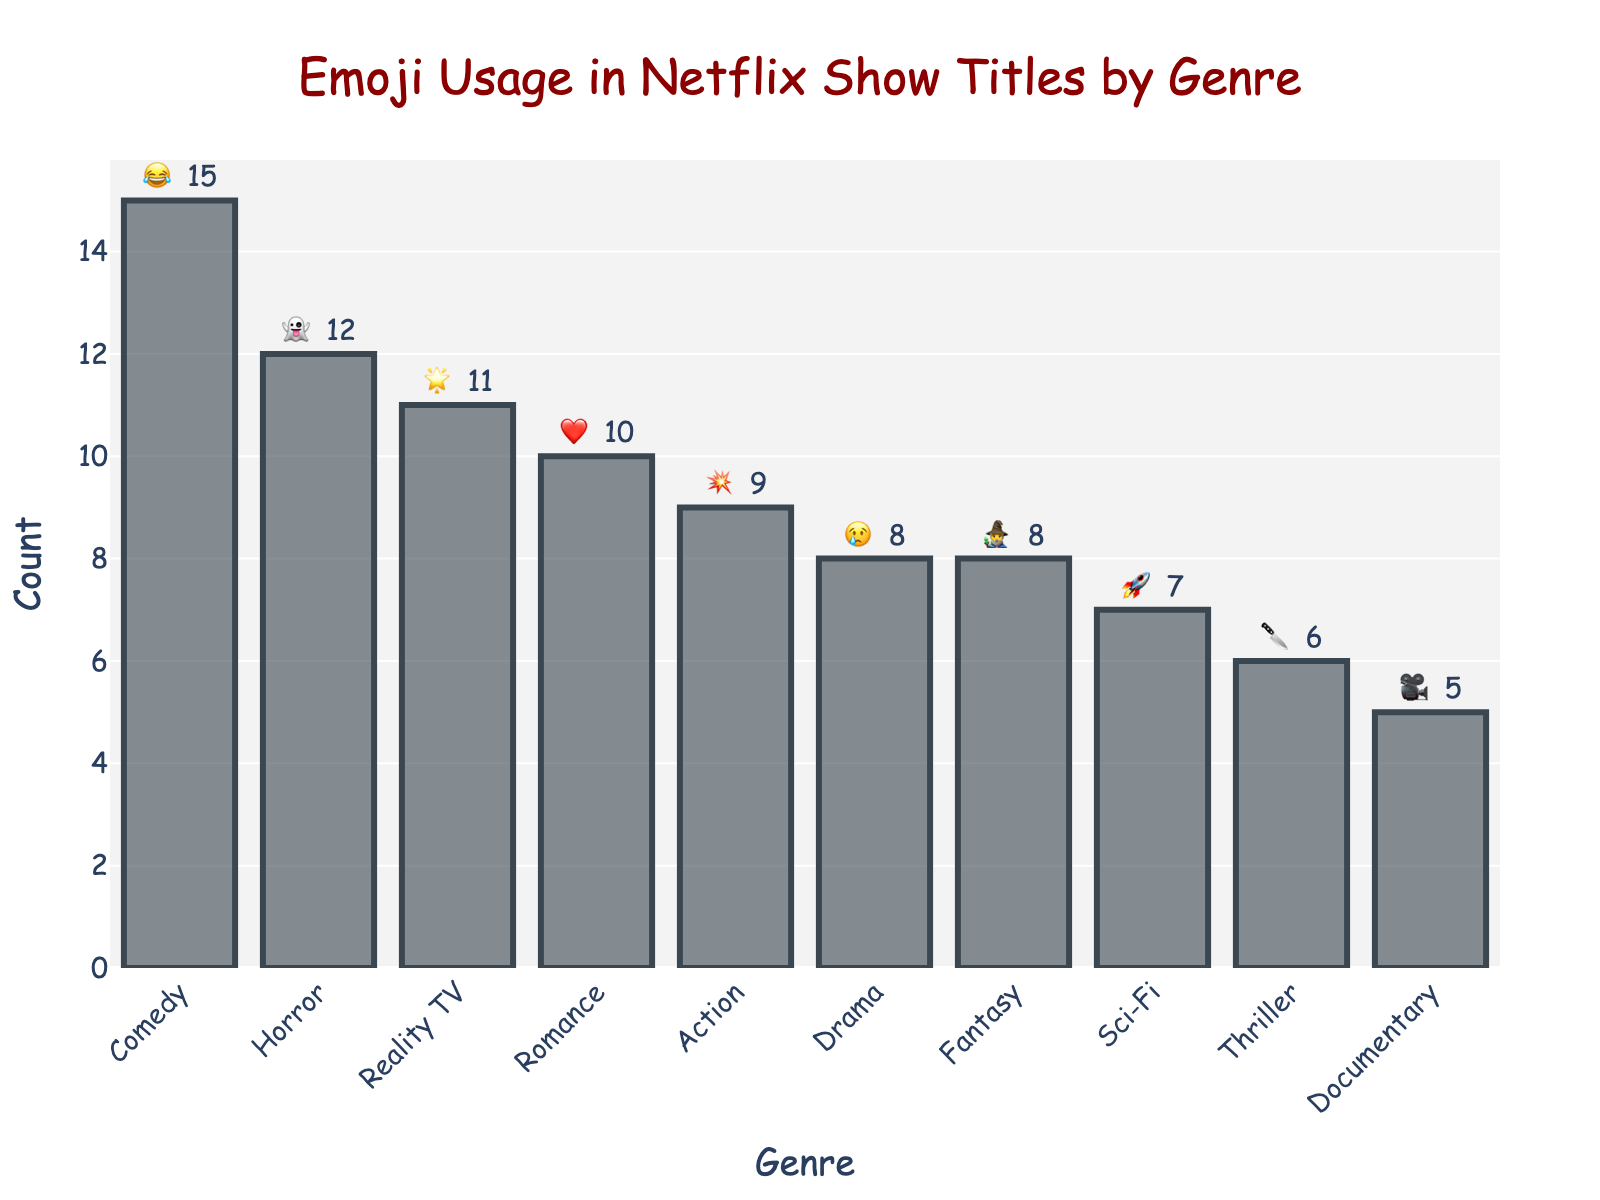Which genre has the highest emoji usage? By examining the height of the bars and the text labels, we can see that Comedy has the highest count of emojis used in Netflix show titles.
Answer: Comedy What is the total number of emojis used in Horror and Fantasy genres? By examining the text labels on the bars, we find that Horror has 12 emojis and Fantasy has 8 emojis. The total is 12 + 8 = 20 emojis.
Answer: 20 Which genre uses the '❤️' emoji, and how many times is it used? Referring to the text labels on the bars, we find that the '❤️' emoji is used in the Romance genre, with a count of 10.
Answer: Romance, 10 How many more times is the '😂' emoji used in Comedy compared to the '🔪' emoji in Thriller? Comedy has 15 emojis (😂) and Thriller has 6 emojis (🔪). The difference is 15 - 6 = 9.
Answer: 9 What is the average number of emojis used across all genres? To find the average, sum up all the emojis and divide by the number of genres. (15 + 8 + 12 + 10 + 9 + 7 + 5 + 6 + 8 + 11) = 91 emojis. There are 10 genres. The average is 91 / 10 = 9.1 emojis.
Answer: 9.1 Which genre uses the emoji '👻', and how many times is it used? By referencing the text labels on the bars, the '👻' emoji is used in the Horror genre, with a count of 12.
Answer: Horror, 12 List the genres that use emojis more than 10 times. By examining the count data, Comedy (15), Horror (12), Romance (10), and Reality TV (11) use emojis more than 10 times.
Answer: Comedy, Horror, Reality TV Among Action, Sci-Fi, and Documentary genres, which one has the highest emoji usage? By comparing the heights of the bars and the text labels, we see that Action has 9 emojis, Sci-Fi has 7 emojis, and Documentary has 5 emojis. The Action genre has the highest usage among the three.
Answer: Action 